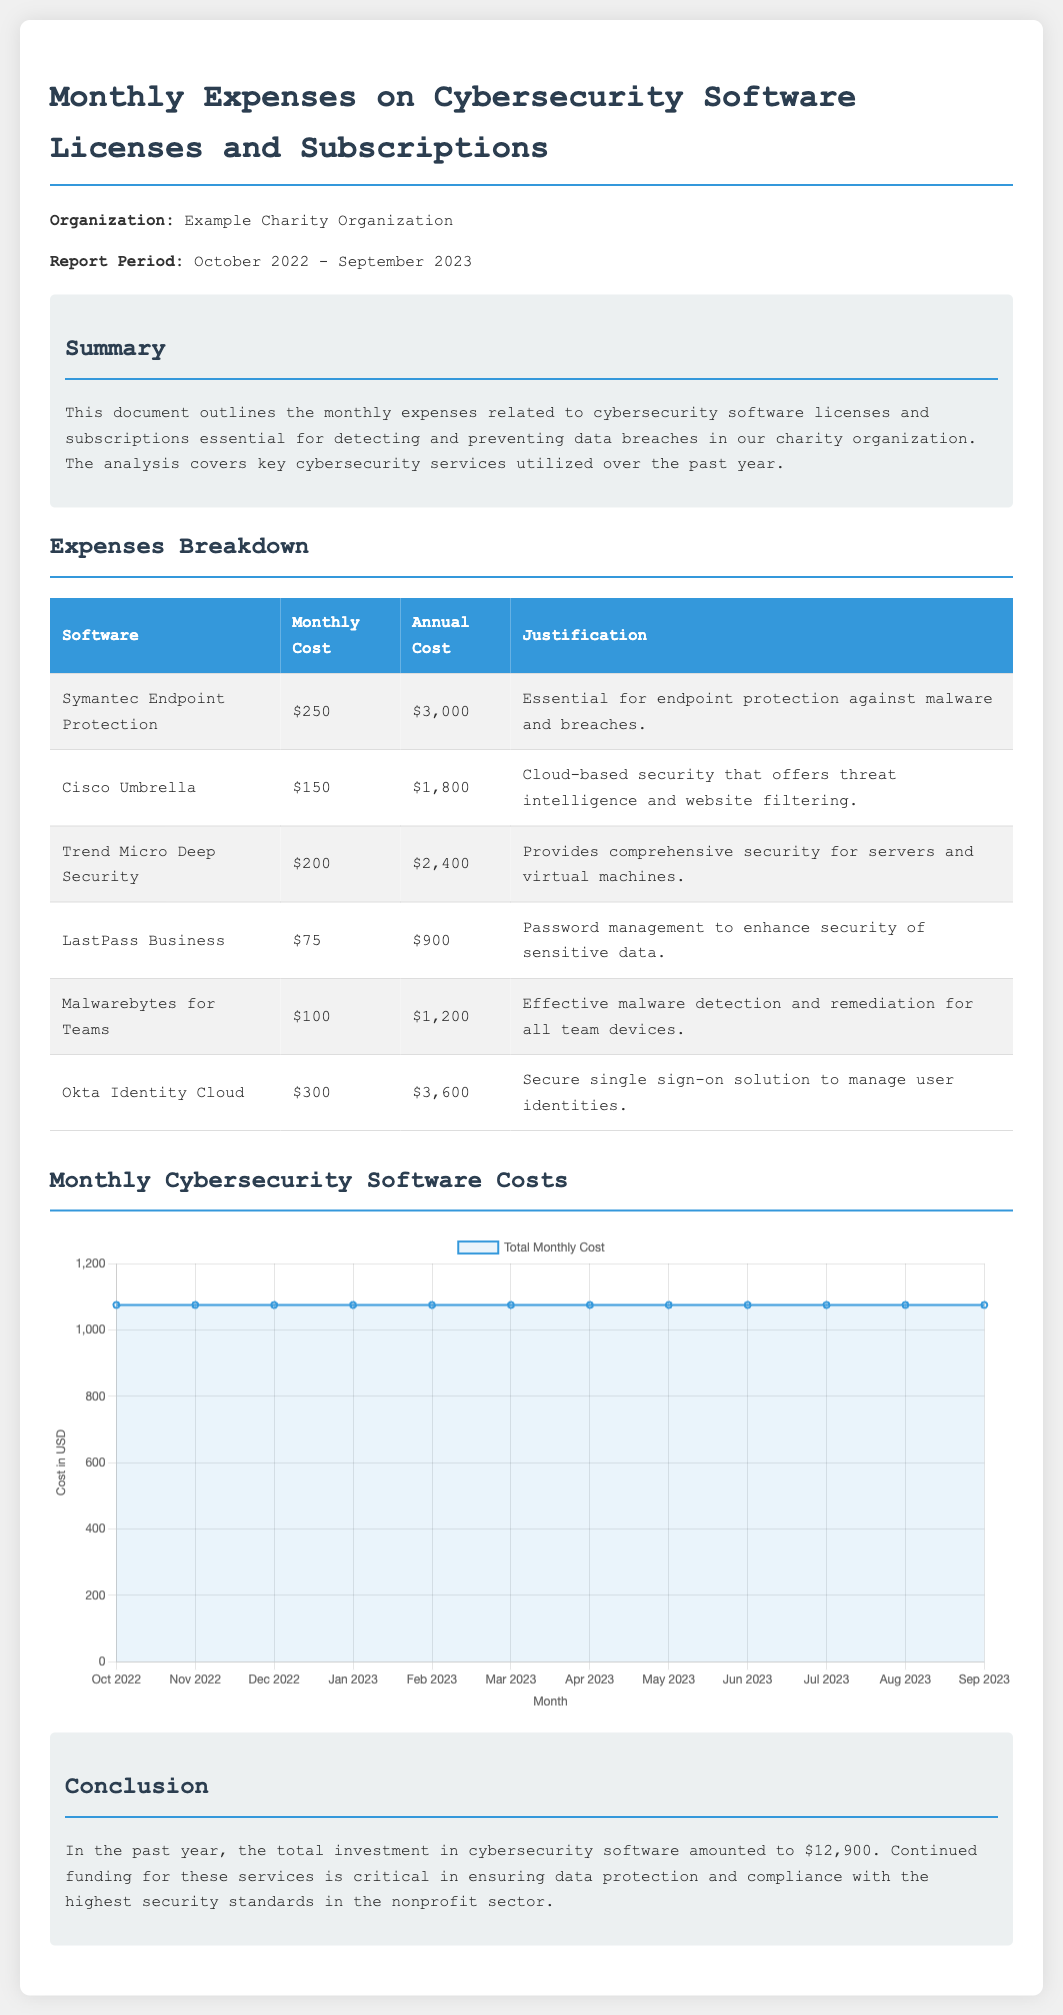What is the total investment in cybersecurity software? The total investment is stated in the conclusion section of the document.
Answer: $12,900 Which software has the highest monthly cost? The answer can be found in the expenses breakdown table by identifying the highest value under "Monthly Cost."
Answer: Okta Identity Cloud What is the monthly cost of LastPass Business? The monthly cost for LastPass Business is listed in the expenses breakdown table.
Answer: $75 For how many months does this report cover? The report period indicates the coverage from October 2022 to September 2023, which can be calculated.
Answer: 12 months What type of chart is used in the document? The type of chart is specified in the script section of the document, describing the visualization.
Answer: Line Which month had an expense of $1,075? The data points in the chart indicate that all months have the same cost shown in the dataset.
Answer: Every month What is the justification for using Cisco Umbrella? The purpose of Cisco Umbrella is provided in the expenses breakdown table under "Justification."
Answer: Cloud-based security that offers threat intelligence and website filtering How many software licenses are listed in the expenses breakdown? By counting the number of rows in the table, excluding the header, one can determine the count.
Answer: 6 What is the annual cost of Symantec Endpoint Protection? The annual cost is mentioned in the expenses breakdown table next to the respective software name.
Answer: $3,000 What is the average monthly cost of the listed cybersecurity software? Total annual cost divided by 12 months provides the average; this needs to be calculated using the data.
Answer: $1,075 